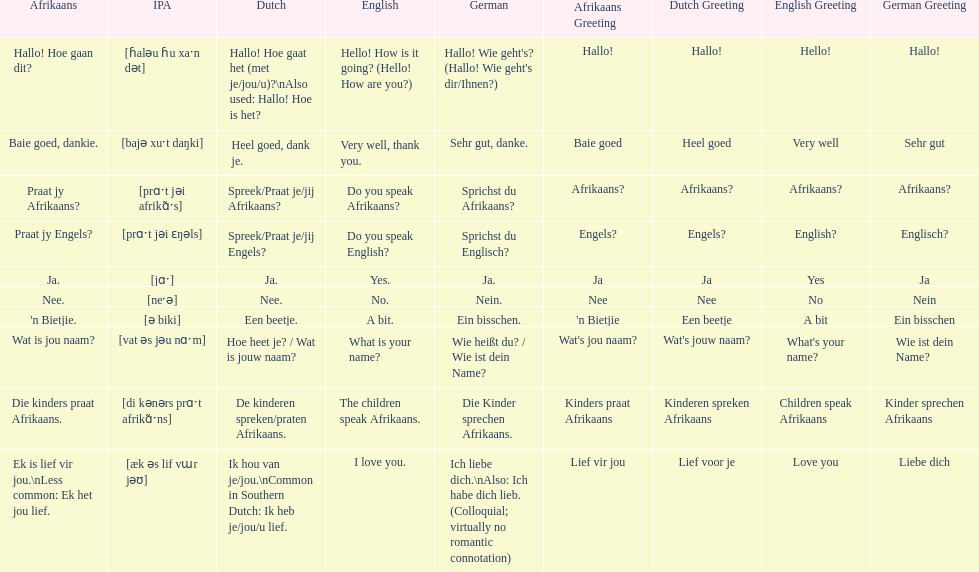How do you say 'yes' in afrikaans? Ja. 